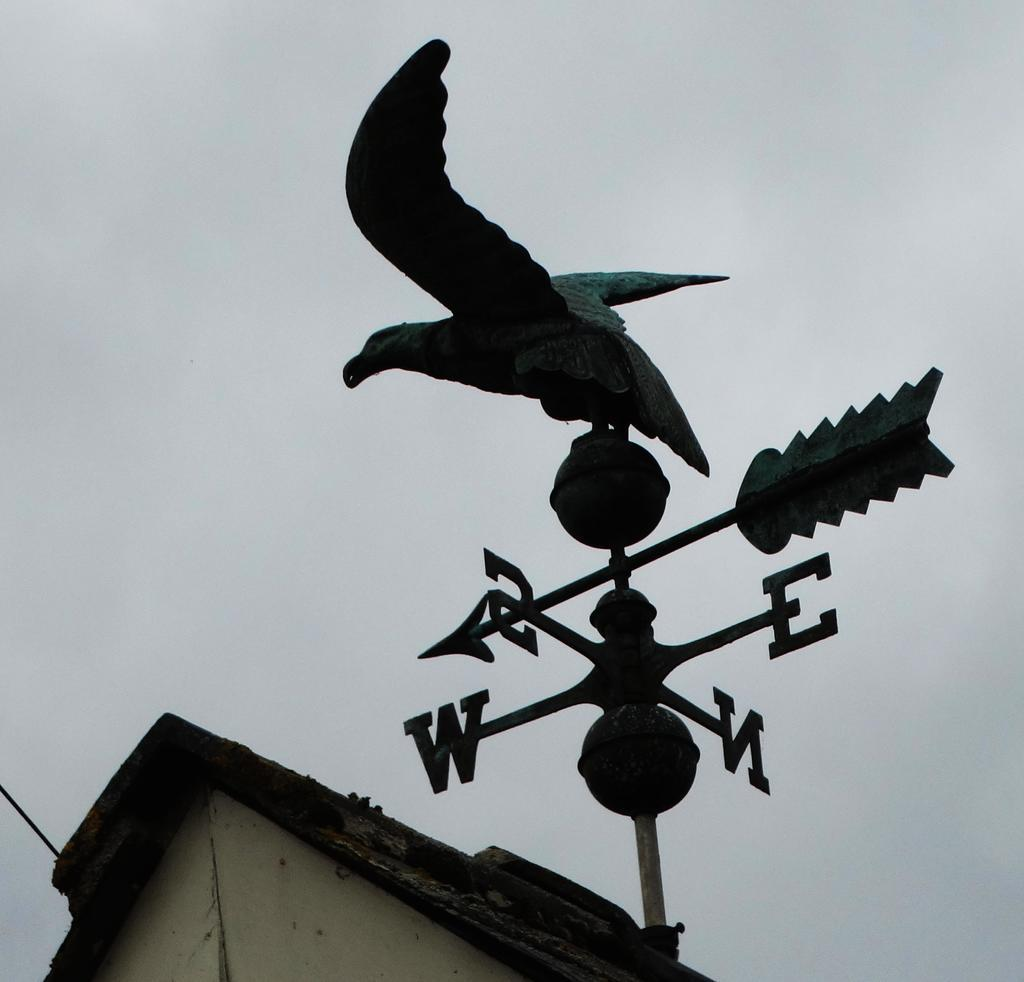What object can be seen in the image that indicates the direction of the wind? There is a wind vane in the image. What is depicted on the wind vane? The wind vane has a bird sculpture on it. What structure is located near the wind vane? There is a building beside the wind vane. Reasoning: Let's: Let's think step by step in order to produce the conversation. We start by identifying the main subject of the image, which is the wind vane. Then, we describe the specific features of the wind vane, such as the bird sculpture. Finally, we mention the nearby structure, which is the building. Each question is designed to elicit a specific detail about the image that is known from the provided facts. Absurd Question/Answer: What type of fiction book is the wind vane holding in the image? There is no fiction book present in the image; the wind vane has a bird sculpture on it. Can you see any bombs in the image? There are no bombs present in the image. 